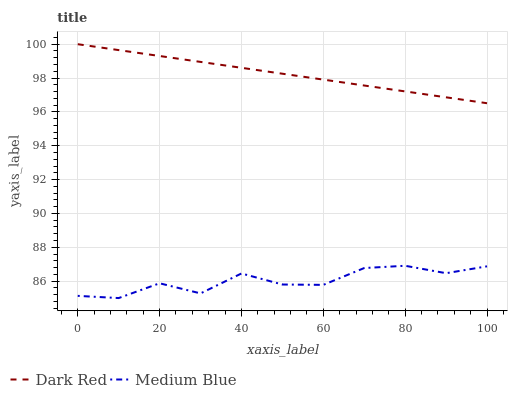Does Medium Blue have the minimum area under the curve?
Answer yes or no. Yes. Does Dark Red have the maximum area under the curve?
Answer yes or no. Yes. Does Medium Blue have the maximum area under the curve?
Answer yes or no. No. Is Dark Red the smoothest?
Answer yes or no. Yes. Is Medium Blue the roughest?
Answer yes or no. Yes. Is Medium Blue the smoothest?
Answer yes or no. No. Does Medium Blue have the lowest value?
Answer yes or no. Yes. Does Dark Red have the highest value?
Answer yes or no. Yes. Does Medium Blue have the highest value?
Answer yes or no. No. Is Medium Blue less than Dark Red?
Answer yes or no. Yes. Is Dark Red greater than Medium Blue?
Answer yes or no. Yes. Does Medium Blue intersect Dark Red?
Answer yes or no. No. 